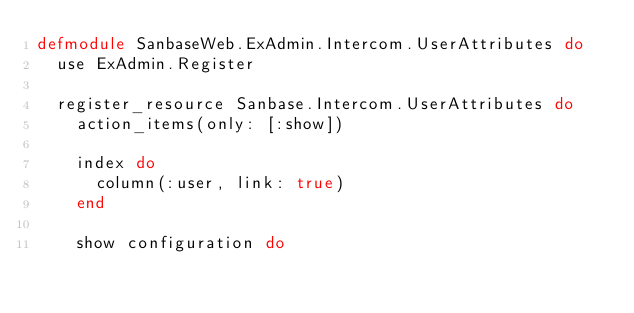<code> <loc_0><loc_0><loc_500><loc_500><_Elixir_>defmodule SanbaseWeb.ExAdmin.Intercom.UserAttributes do
  use ExAdmin.Register

  register_resource Sanbase.Intercom.UserAttributes do
    action_items(only: [:show])

    index do
      column(:user, link: true)
    end

    show configuration do</code> 